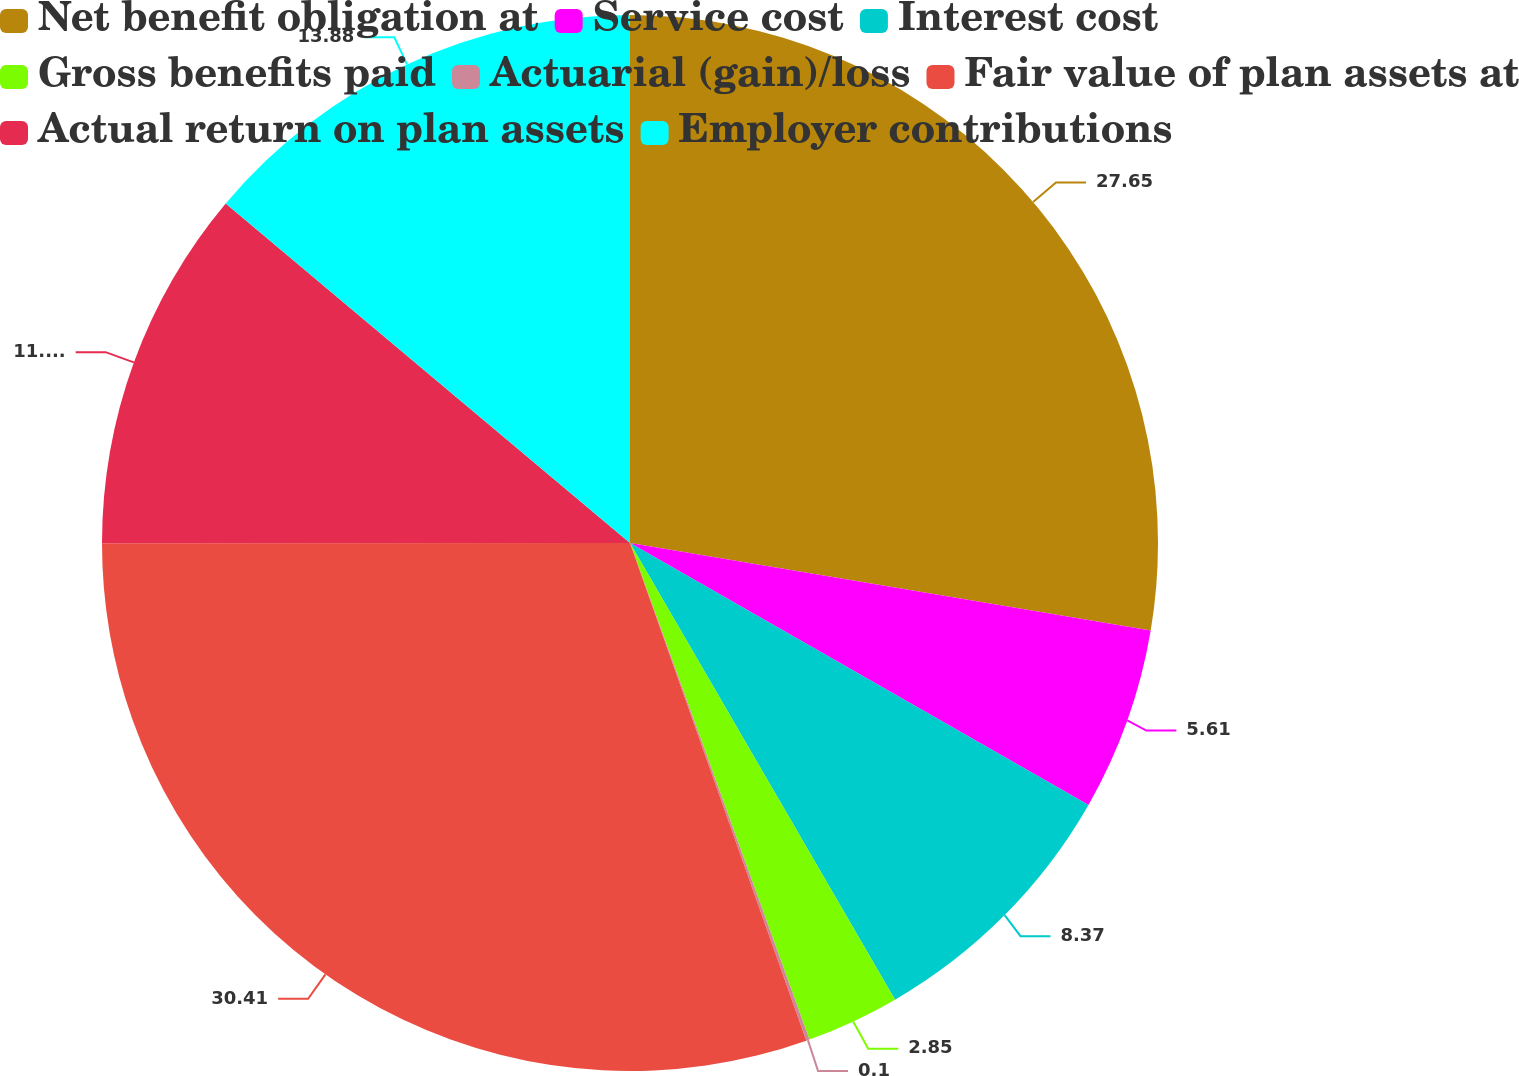<chart> <loc_0><loc_0><loc_500><loc_500><pie_chart><fcel>Net benefit obligation at<fcel>Service cost<fcel>Interest cost<fcel>Gross benefits paid<fcel>Actuarial (gain)/loss<fcel>Fair value of plan assets at<fcel>Actual return on plan assets<fcel>Employer contributions<nl><fcel>27.65%<fcel>5.61%<fcel>8.37%<fcel>2.85%<fcel>0.1%<fcel>30.41%<fcel>11.13%<fcel>13.88%<nl></chart> 